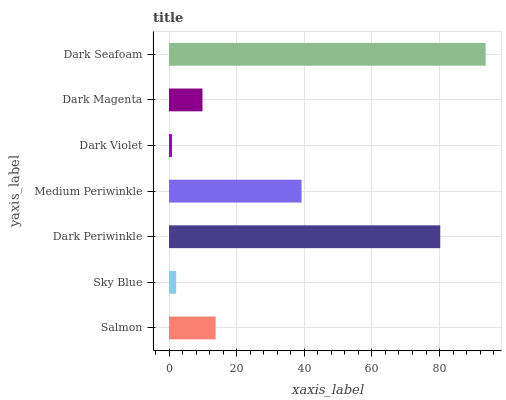Is Dark Violet the minimum?
Answer yes or no. Yes. Is Dark Seafoam the maximum?
Answer yes or no. Yes. Is Sky Blue the minimum?
Answer yes or no. No. Is Sky Blue the maximum?
Answer yes or no. No. Is Salmon greater than Sky Blue?
Answer yes or no. Yes. Is Sky Blue less than Salmon?
Answer yes or no. Yes. Is Sky Blue greater than Salmon?
Answer yes or no. No. Is Salmon less than Sky Blue?
Answer yes or no. No. Is Salmon the high median?
Answer yes or no. Yes. Is Salmon the low median?
Answer yes or no. Yes. Is Sky Blue the high median?
Answer yes or no. No. Is Dark Periwinkle the low median?
Answer yes or no. No. 